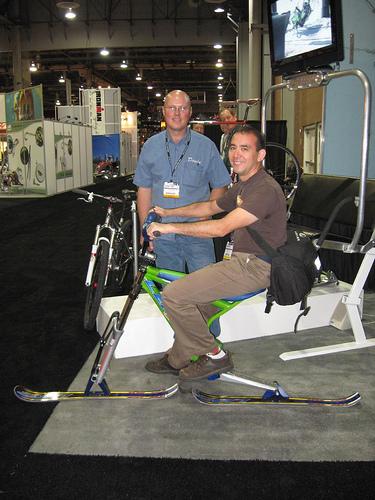Is the person wearing work uniform?
Write a very short answer. Yes. What is this man riding?
Write a very short answer. Ski bike. Are they happy?
Be succinct. Yes. Does the man look like he's doing something interesting?
Short answer required. Yes. 